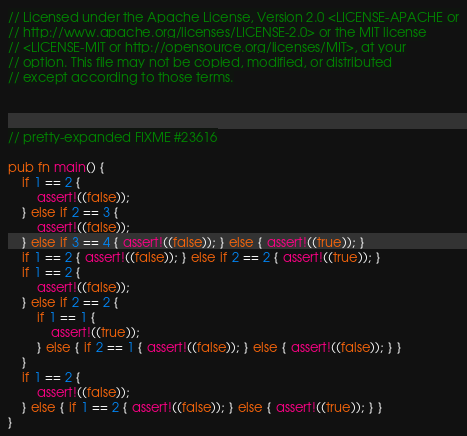Convert code to text. <code><loc_0><loc_0><loc_500><loc_500><_Rust_>// Licensed under the Apache License, Version 2.0 <LICENSE-APACHE or
// http://www.apache.org/licenses/LICENSE-2.0> or the MIT license
// <LICENSE-MIT or http://opensource.org/licenses/MIT>, at your
// option. This file may not be copied, modified, or distributed
// except according to those terms.



// pretty-expanded FIXME #23616

pub fn main() {
    if 1 == 2 {
        assert!((false));
    } else if 2 == 3 {
        assert!((false));
    } else if 3 == 4 { assert!((false)); } else { assert!((true)); }
    if 1 == 2 { assert!((false)); } else if 2 == 2 { assert!((true)); }
    if 1 == 2 {
        assert!((false));
    } else if 2 == 2 {
        if 1 == 1 {
            assert!((true));
        } else { if 2 == 1 { assert!((false)); } else { assert!((false)); } }
    }
    if 1 == 2 {
        assert!((false));
    } else { if 1 == 2 { assert!((false)); } else { assert!((true)); } }
}
</code> 